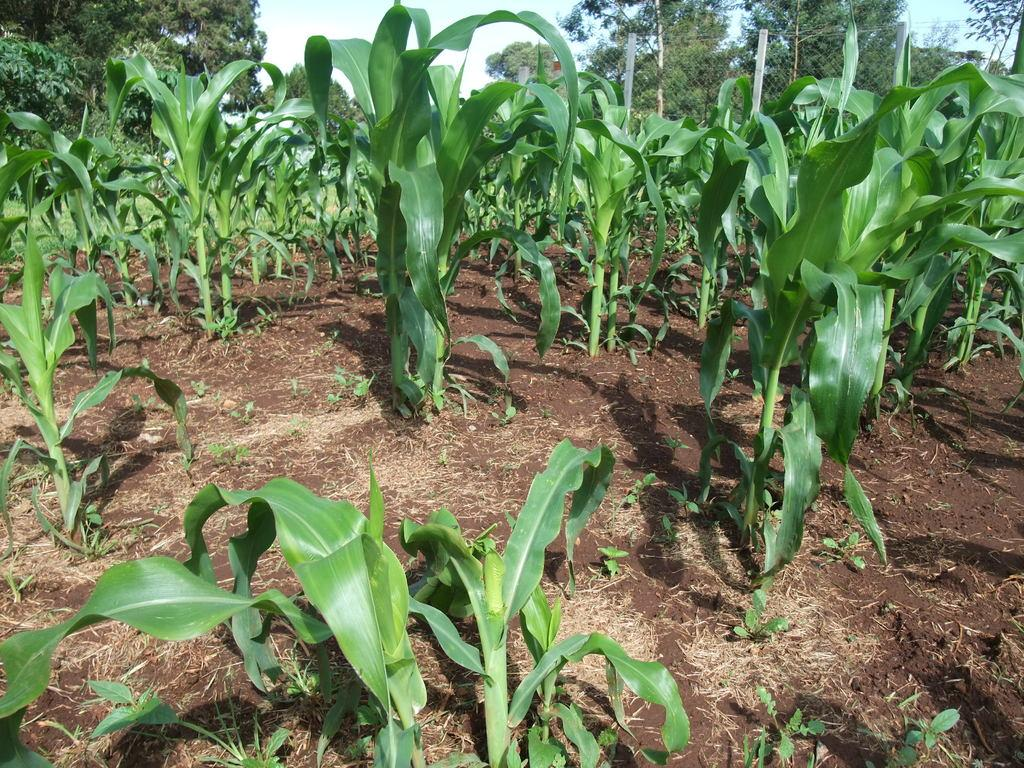What type of vegetation can be seen in the background of the image? There are plants in the background of the image. What else can be seen in the background of the image? There is ground visible in the background of the image. What is located at the top of the image? There are trees and a mesh at the top of the image. What is visible beyond the trees and mesh at the top of the image? The sky is visible at the top of the image. What degree of difficulty is the cake being served at the top of the image? There is no cake present in the image, so it is not possible to determine the degree of difficulty. 